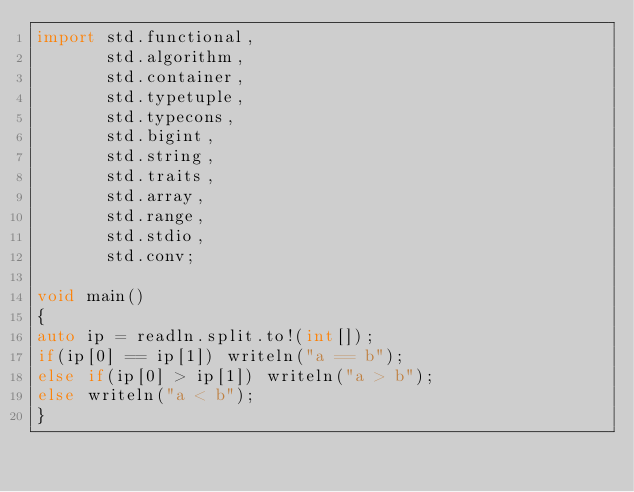<code> <loc_0><loc_0><loc_500><loc_500><_D_>import std.functional,
       std.algorithm,
       std.container,
       std.typetuple,
       std.typecons,
       std.bigint,
       std.string,
       std.traits,
       std.array,
       std.range,
       std.stdio,
       std.conv;

void main()
{
auto ip = readln.split.to!(int[]);
if(ip[0] == ip[1]) writeln("a == b");
else if(ip[0] > ip[1]) writeln("a > b");
else writeln("a < b");
}
</code> 